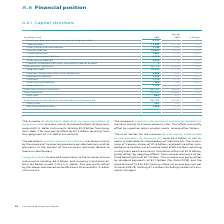According to Siemens Ag's financial document, What caused the increase in short-term debt and current maturities of long-term debt  Based on the financial document, the answer is The increase in short-term debt and current maturities of long-term debt was due mainly to reclassifications of long-term euro and U. S. dollar instruments totaling € 3.9 billion from longterm debt. This was partly offset by € 3.3 billion resulting from the repayment of U. S. dollar instruments.. Also, What caused the decrease in current income tax liability? The decrease in current income tax liabilities was driven mainly by the reversal of income tax provisions outside Germany and tax payments in the context of the carve-out activities related to Siemens Healthineers.. The document states: "The decrease in current income tax liabilities was driven mainly by the reversal of income tax provisions outside Germany and tax payments in the cont..." Also, What caused the long-term debt to increase? Based on the financial document, the answer is Long-term debt increased due primarily to the issuance of euro instruments totaling € 6.5 billion and currency translation effects for bonds issued in the U. S. dollar. This was partly offset by the above-mentioned reclassifications of euro and U. S. dollar instruments.. Also, can you calculate: What were the average trade payables in 2019 and 2018? To answer this question, I need to perform calculations using the financial data. The calculation is: (11,409 + 10,716) / 2, which equals 11062.5 (in millions). This is based on the information: "Trade payables 11,409 10,716 6 % Trade payables 11,409 10,716 6 %..." The key data points involved are: 10,716, 11,409. Also, can you calculate: What is the increase / (decrease) in total current liabilities from 2018 to 2019? Based on the calculation: 50,723 - 47,874, the result is 2849 (in millions). This is based on the information: "Total current liabilities 50,723 47,874 6 % Total current liabilities 50,723 47,874 6 %..." The key data points involved are: 47,874, 50,723. Also, can you calculate: What is the percentage increase / (decrease) in total liabilities and equity from 2018 to 2019? To answer this question, I need to perform calculations using the financial data. The calculation is: 150,248 / 138,915 - 1, which equals 8.16 (percentage). This is based on the information: "Total liabilities and equity 150,248 138,915 8 % Total liabilities and equity 150,248 138,915 8 %..." The key data points involved are: 138,915, 150,248. 